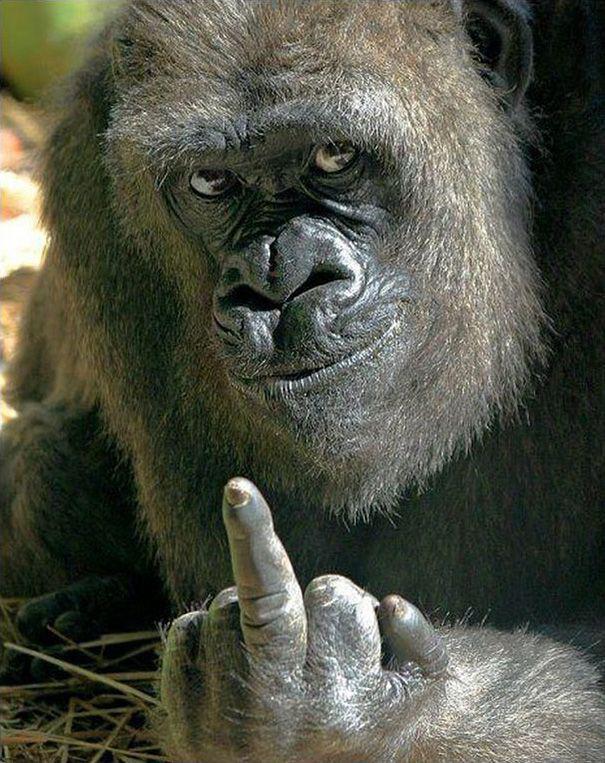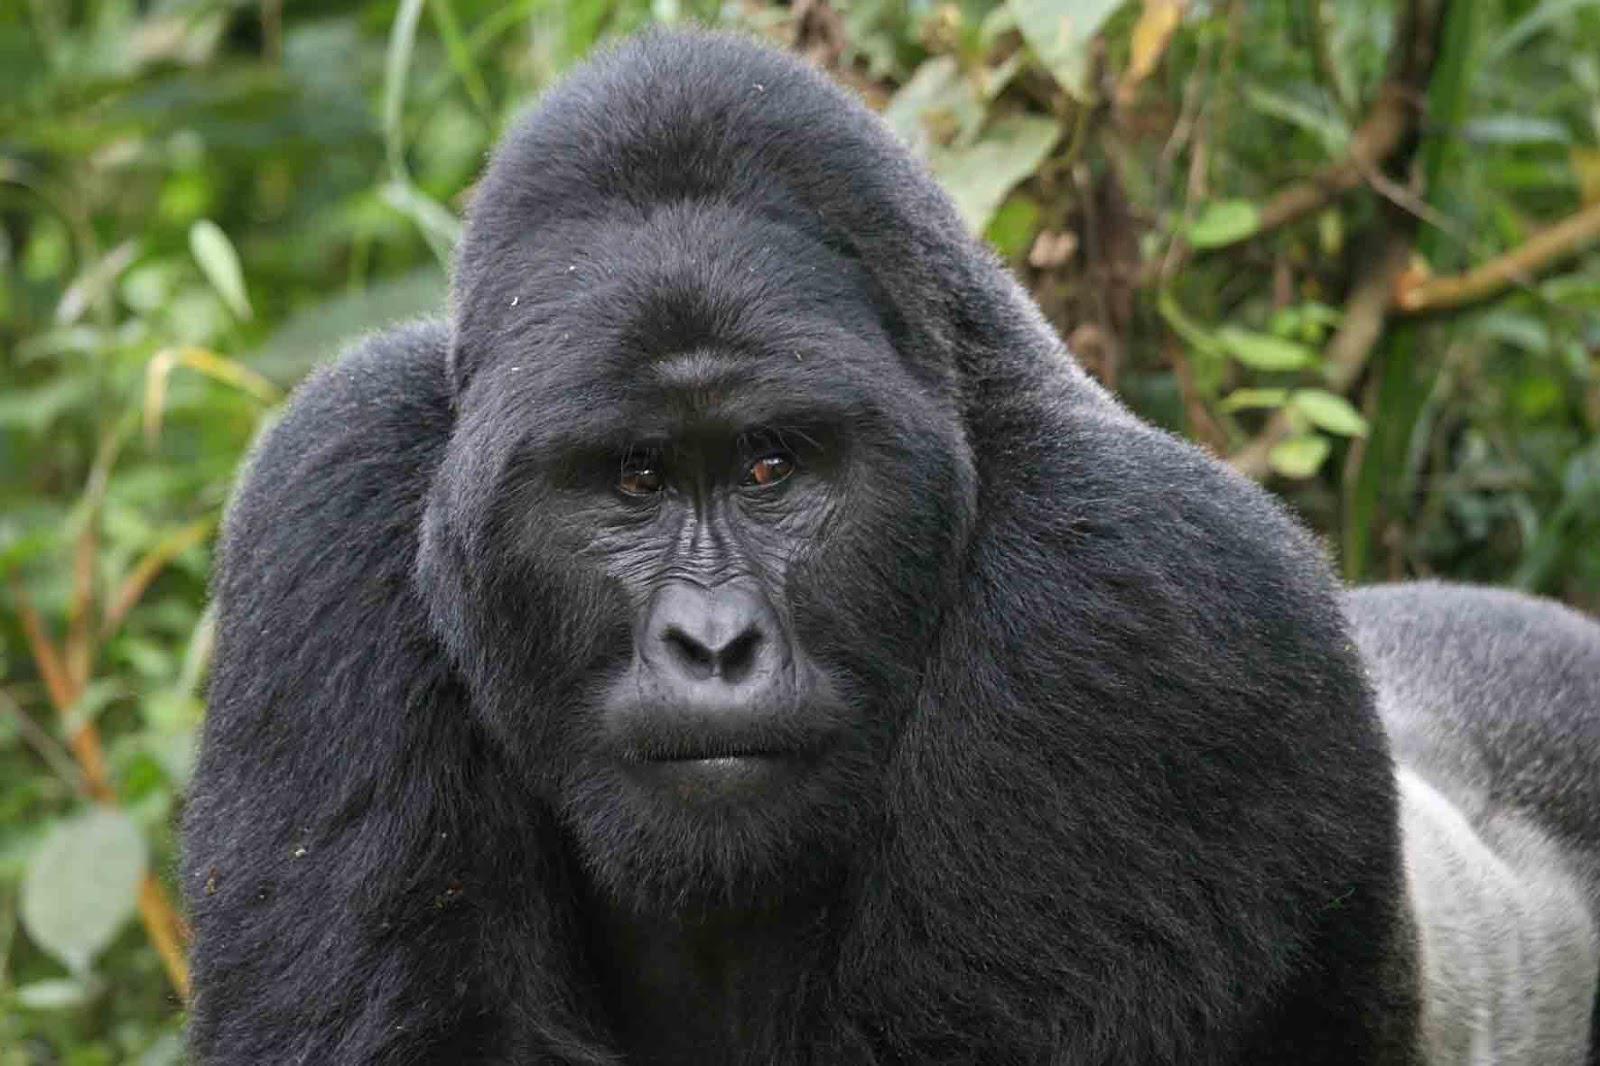The first image is the image on the left, the second image is the image on the right. For the images displayed, is the sentence "There is a large gorilla in one image and at least a baby gorilla in the other image." factually correct? Answer yes or no. No. The first image is the image on the left, the second image is the image on the right. Examine the images to the left and right. Is the description "The right image includes a fluffy baby gorilla with its tongue visible." accurate? Answer yes or no. No. 